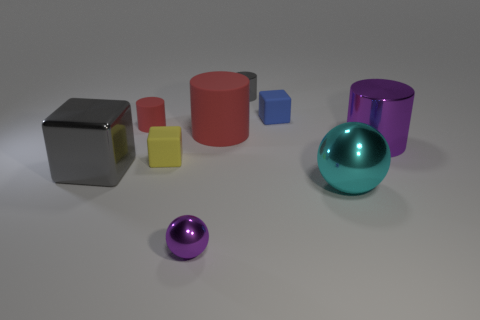Subtract 1 cylinders. How many cylinders are left? 3 Subtract all brown cylinders. Subtract all gray blocks. How many cylinders are left? 4 Subtract all cylinders. How many objects are left? 5 Subtract all big things. Subtract all gray blocks. How many objects are left? 4 Add 7 large shiny objects. How many large shiny objects are left? 10 Add 9 small brown cylinders. How many small brown cylinders exist? 9 Subtract 0 brown cylinders. How many objects are left? 9 